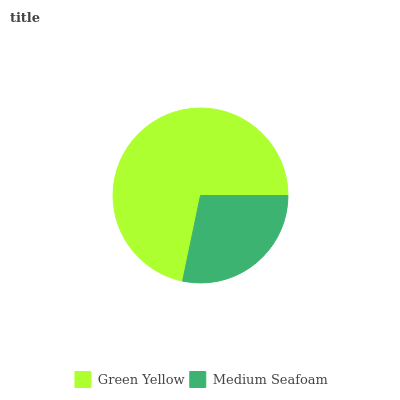Is Medium Seafoam the minimum?
Answer yes or no. Yes. Is Green Yellow the maximum?
Answer yes or no. Yes. Is Medium Seafoam the maximum?
Answer yes or no. No. Is Green Yellow greater than Medium Seafoam?
Answer yes or no. Yes. Is Medium Seafoam less than Green Yellow?
Answer yes or no. Yes. Is Medium Seafoam greater than Green Yellow?
Answer yes or no. No. Is Green Yellow less than Medium Seafoam?
Answer yes or no. No. Is Green Yellow the high median?
Answer yes or no. Yes. Is Medium Seafoam the low median?
Answer yes or no. Yes. Is Medium Seafoam the high median?
Answer yes or no. No. Is Green Yellow the low median?
Answer yes or no. No. 